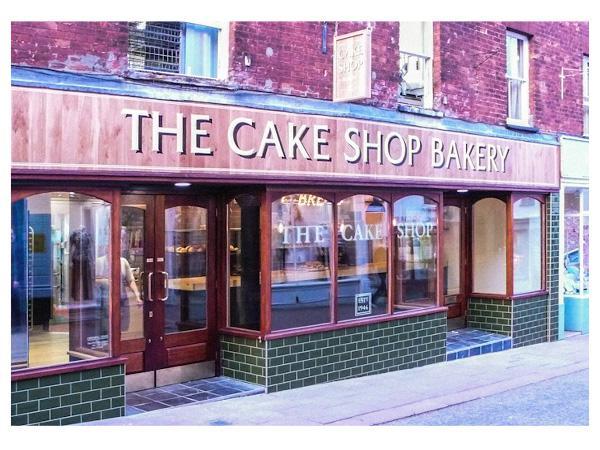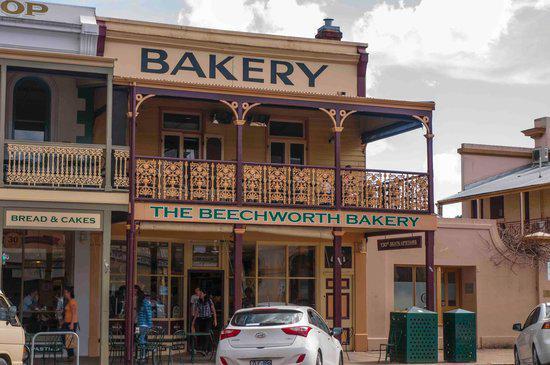The first image is the image on the left, the second image is the image on the right. Assess this claim about the two images: "The front door is wide open in some of the pictures.". Correct or not? Answer yes or no. No. The first image is the image on the left, the second image is the image on the right. Examine the images to the left and right. Is the description "There is at least one chair outside in front of a building." accurate? Answer yes or no. Yes. 